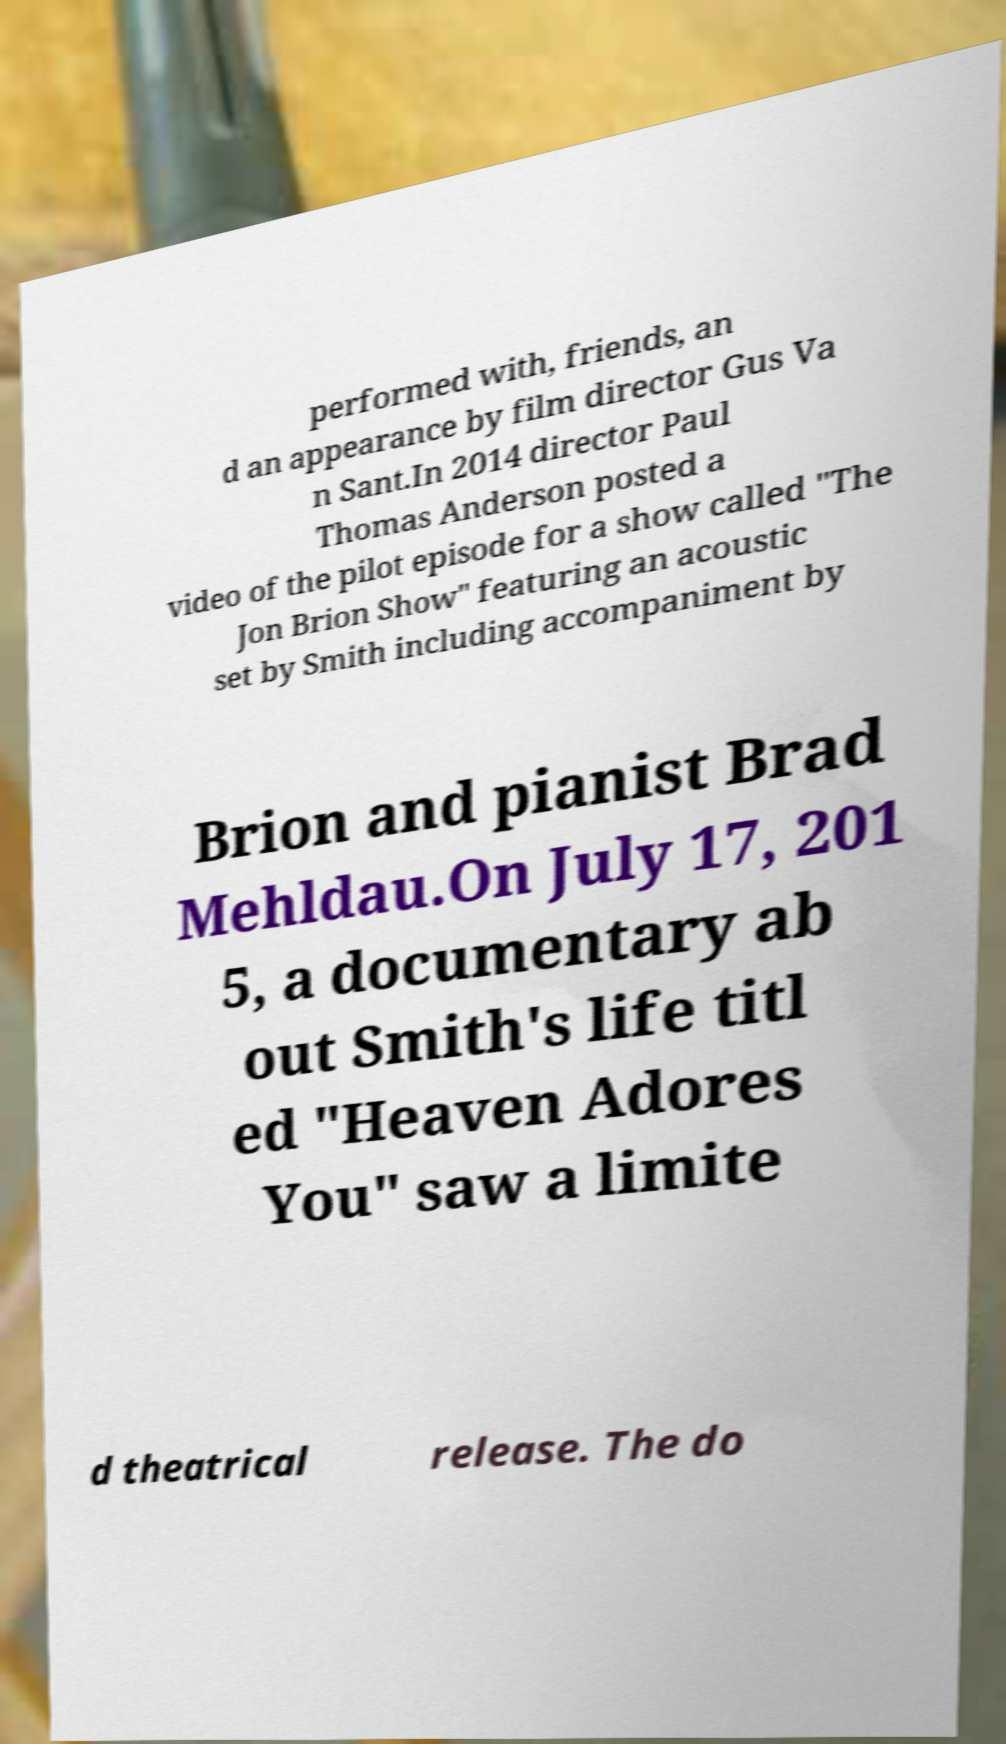What messages or text are displayed in this image? I need them in a readable, typed format. performed with, friends, an d an appearance by film director Gus Va n Sant.In 2014 director Paul Thomas Anderson posted a video of the pilot episode for a show called "The Jon Brion Show" featuring an acoustic set by Smith including accompaniment by Brion and pianist Brad Mehldau.On July 17, 201 5, a documentary ab out Smith's life titl ed "Heaven Adores You" saw a limite d theatrical release. The do 